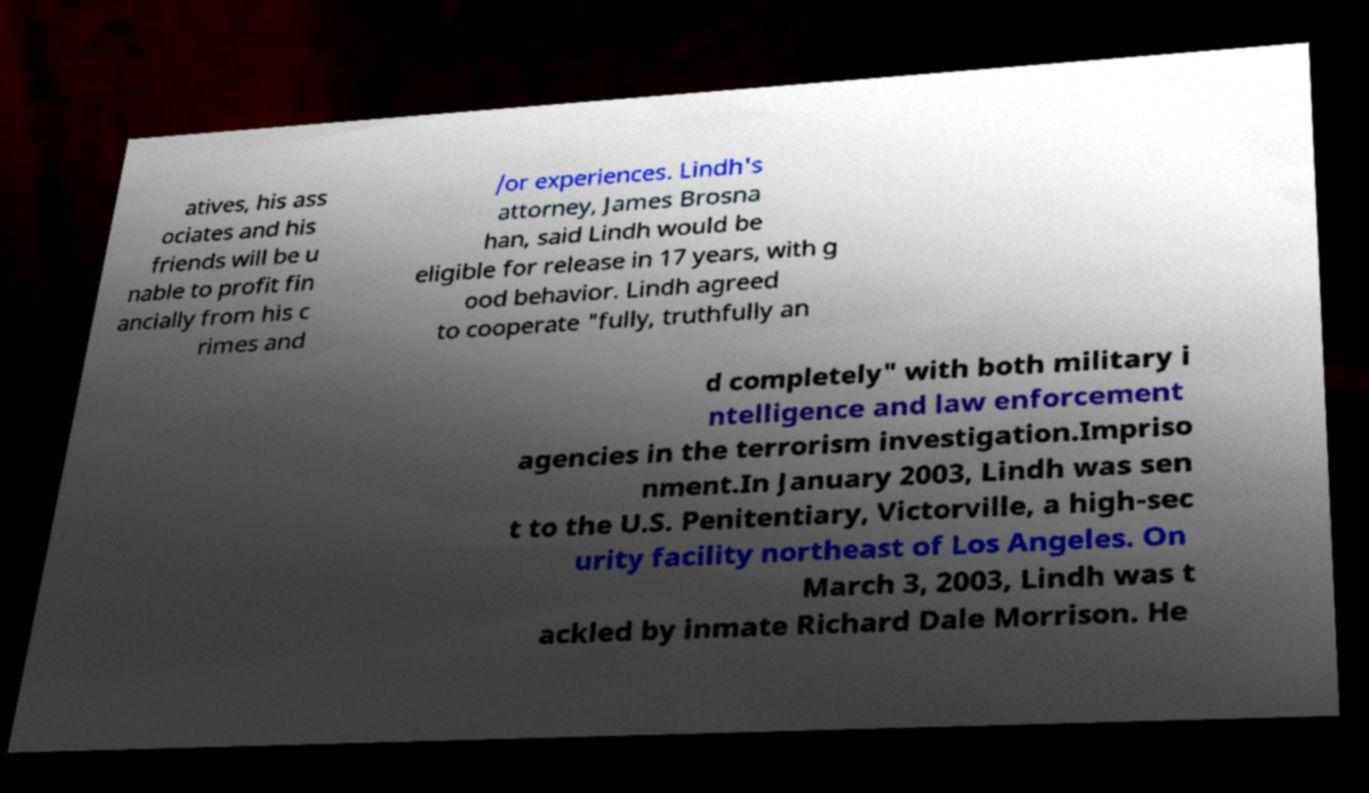What messages or text are displayed in this image? I need them in a readable, typed format. atives, his ass ociates and his friends will be u nable to profit fin ancially from his c rimes and /or experiences. Lindh's attorney, James Brosna han, said Lindh would be eligible for release in 17 years, with g ood behavior. Lindh agreed to cooperate "fully, truthfully an d completely" with both military i ntelligence and law enforcement agencies in the terrorism investigation.Impriso nment.In January 2003, Lindh was sen t to the U.S. Penitentiary, Victorville, a high-sec urity facility northeast of Los Angeles. On March 3, 2003, Lindh was t ackled by inmate Richard Dale Morrison. He 